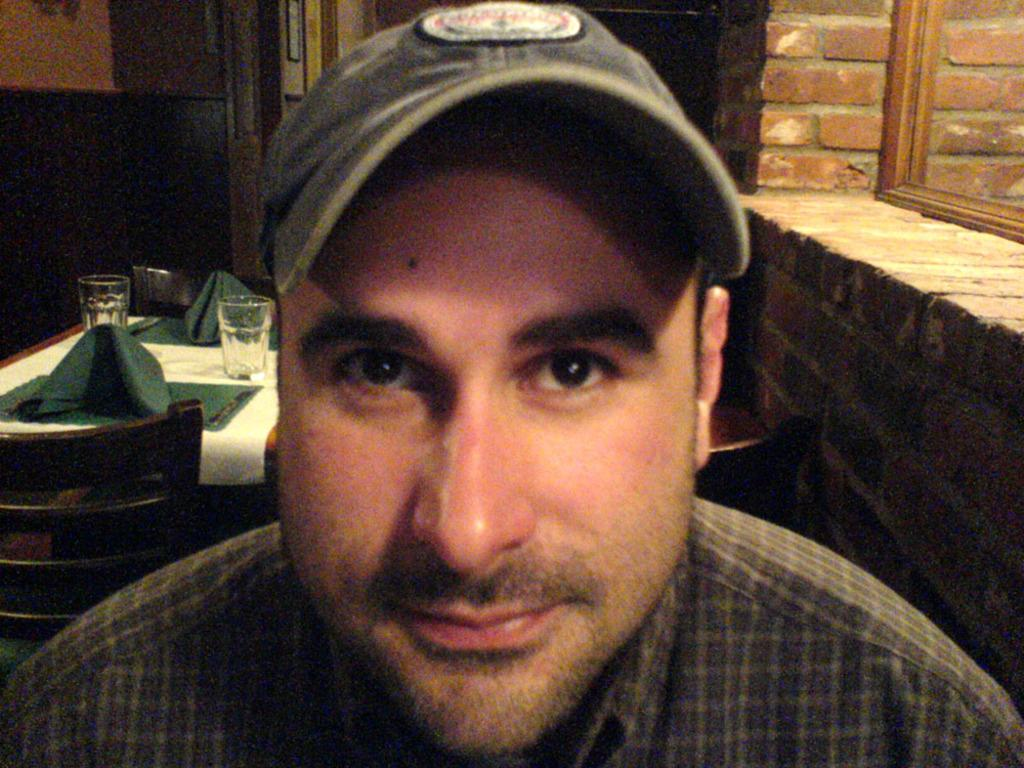Who is present in the image? There is a man in the image. What is on the table in the image? There are glasses and green objects on the table in the image. What is the color of the cloth in the image? The cloth in the image is white. What is the table made of? The table in the image is made of wood. What can be seen in the background of the image? There is a brick wall in the background of the image. What type of van can be seen in the image? There is no van present in the image. How many elbows can be seen in the image? There are no elbows visible in the image; it features a man, glasses, green objects, a white cloth, a wooden table, and a brick wall in the background. 